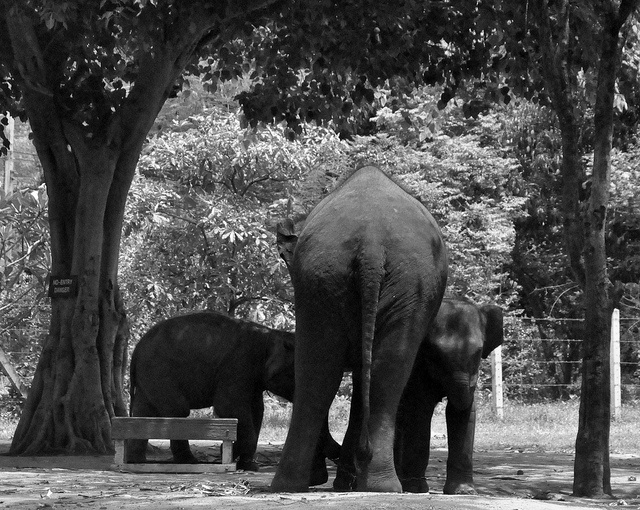Describe the objects in this image and their specific colors. I can see elephant in black, gray, and lightgray tones, elephant in black, gray, darkgray, and lightgray tones, elephant in black, gray, and lightgray tones, and bench in black, gray, darkgray, and lightgray tones in this image. 